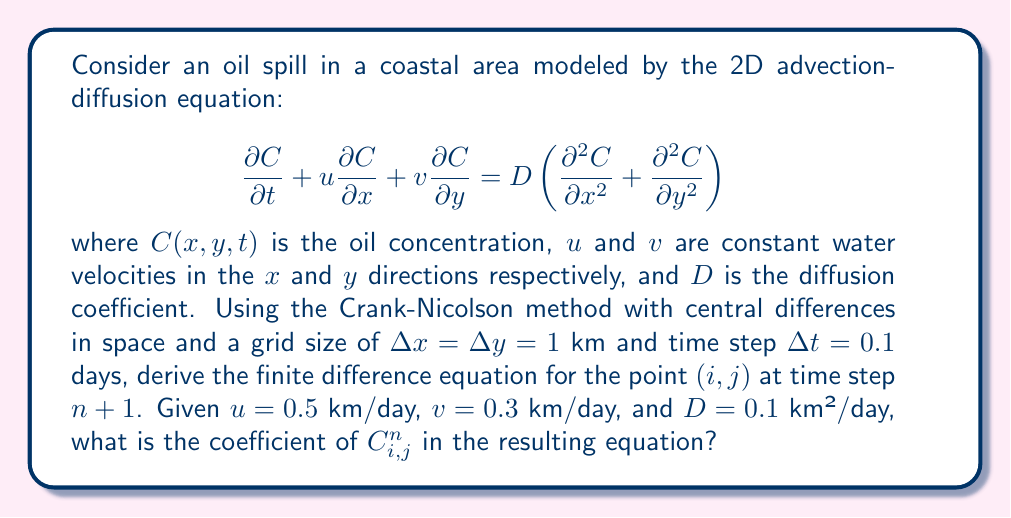Help me with this question. To solve this problem, we'll follow these steps:

1) First, we'll apply the Crank-Nicolson method, which averages the spatial derivatives between time steps $n$ and $n+1$:

   $$\frac{C_{i,j}^{n+1} - C_{i,j}^n}{\Delta t} + \frac{u}{2}\left(\frac{\partial C}{\partial x}\right)_{i,j}^{n+1} + \frac{u}{2}\left(\frac{\partial C}{\partial x}\right)_{i,j}^n + \frac{v}{2}\left(\frac{\partial C}{\partial y}\right)_{i,j}^{n+1} + \frac{v}{2}\left(\frac{\partial C}{\partial y}\right)_{i,j}^n = \frac{D}{2}\left(\frac{\partial^2 C}{\partial x^2} + \frac{\partial^2 C}{\partial y^2}\right)_{i,j}^{n+1} + \frac{D}{2}\left(\frac{\partial^2 C}{\partial x^2} + \frac{\partial^2 C}{\partial y^2}\right)_{i,j}^n$$

2) Now, we'll replace the spatial derivatives with central differences:

   $$\frac{\partial C}{\partial x} \approx \frac{C_{i+1,j} - C_{i-1,j}}{2\Delta x}$$
   $$\frac{\partial C}{\partial y} \approx \frac{C_{i,j+1} - C_{i,j-1}}{2\Delta y}$$
   $$\frac{\partial^2 C}{\partial x^2} \approx \frac{C_{i+1,j} - 2C_{i,j} + C_{i-1,j}}{\Delta x^2}$$
   $$\frac{\partial^2 C}{\partial y^2} \approx \frac{C_{i,j+1} - 2C_{i,j} + C_{i,j-1}}{\Delta y^2}$$

3) Substituting these into our equation:

   $$\frac{C_{i,j}^{n+1} - C_{i,j}^n}{\Delta t} + \frac{u}{4\Delta x}(C_{i+1,j}^{n+1} - C_{i-1,j}^{n+1} + C_{i+1,j}^n - C_{i-1,j}^n) + \frac{v}{4\Delta y}(C_{i,j+1}^{n+1} - C_{i,j-1}^{n+1} + C_{i,j+1}^n - C_{i,j-1}^n) = \frac{D}{2\Delta x^2}(C_{i+1,j}^{n+1} - 2C_{i,j}^{n+1} + C_{i-1,j}^{n+1} + C_{i+1,j}^n - 2C_{i,j}^n + C_{i-1,j}^n) + \frac{D}{2\Delta y^2}(C_{i,j+1}^{n+1} - 2C_{i,j}^{n+1} + C_{i,j-1}^{n+1} + C_{i,j+1}^n - 2C_{i,j}^n + C_{i,j-1}^n)$$

4) Given $\Delta x = \Delta y = 1$ km and $\Delta t = 0.1$ days, $u = 0.5$ km/day, $v = 0.3$ km/day, and $D = 0.1$ km²/day, we can substitute these values:

   $$\frac{C_{i,j}^{n+1} - C_{i,j}^n}{0.1} + \frac{0.5}{4}(C_{i+1,j}^{n+1} - C_{i-1,j}^{n+1} + C_{i+1,j}^n - C_{i-1,j}^n) + \frac{0.3}{4}(C_{i,j+1}^{n+1} - C_{i,j-1}^{n+1} + C_{i,j+1}^n - C_{i,j-1}^n) = \frac{0.1}{2}(C_{i+1,j}^{n+1} - 2C_{i,j}^{n+1} + C_{i-1,j}^{n+1} + C_{i+1,j}^n - 2C_{i,j}^n + C_{i-1,j}^n) + \frac{0.1}{2}(C_{i,j+1}^{n+1} - 2C_{i,j}^{n+1} + C_{i,j-1}^{n+1} + C_{i,j+1}^n - 2C_{i,j}^n + C_{i,j-1}^n)$$

5) Collecting terms with $C_{i,j}^n$, we get:

   $$C_{i,j}^n(10 - 0.1 - 0.1) = C_{i,j}^n(9.8)$$

Therefore, the coefficient of $C_{i,j}^n$ in the resulting equation is 9.8.
Answer: 9.8 